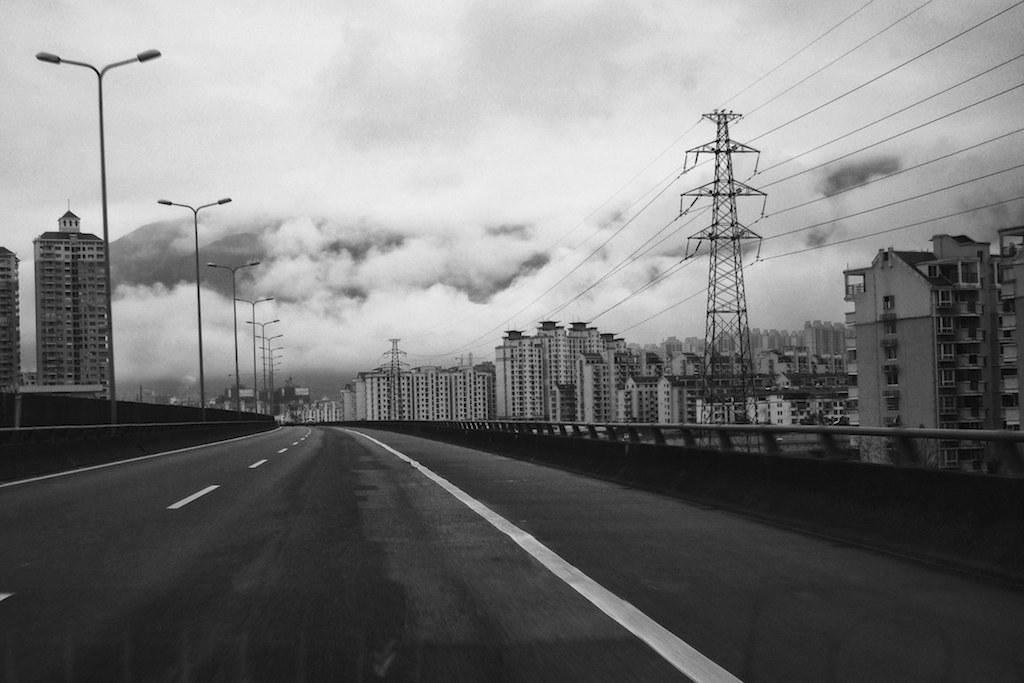In one or two sentences, can you explain what this image depicts? In this picture there is a road bridge. Behind there are many white color buildings and a metal pole with cables. On the left side we can see many street lights. 